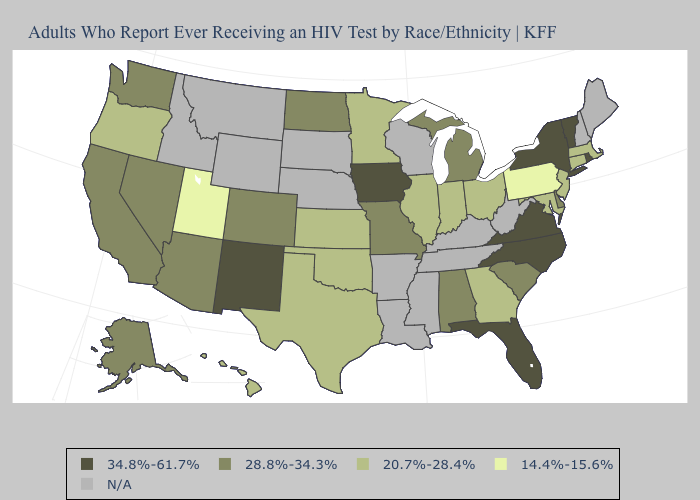What is the lowest value in states that border Indiana?
Short answer required. 20.7%-28.4%. Name the states that have a value in the range 28.8%-34.3%?
Short answer required. Alabama, Alaska, Arizona, California, Colorado, Delaware, Michigan, Missouri, Nevada, North Dakota, South Carolina, Washington. Which states hav the highest value in the West?
Short answer required. New Mexico. Among the states that border Wisconsin , which have the lowest value?
Be succinct. Illinois, Minnesota. Does Ohio have the highest value in the USA?
Give a very brief answer. No. What is the lowest value in the South?
Quick response, please. 20.7%-28.4%. What is the value of Arkansas?
Concise answer only. N/A. Does Arizona have the lowest value in the West?
Short answer required. No. What is the value of New York?
Concise answer only. 34.8%-61.7%. What is the highest value in states that border New Hampshire?
Write a very short answer. 34.8%-61.7%. Which states have the lowest value in the USA?
Keep it brief. Pennsylvania, Utah. What is the lowest value in states that border Oklahoma?
Concise answer only. 20.7%-28.4%. Among the states that border Kentucky , which have the highest value?
Answer briefly. Virginia. Which states have the highest value in the USA?
Write a very short answer. Florida, Iowa, New Mexico, New York, North Carolina, Rhode Island, Vermont, Virginia. 